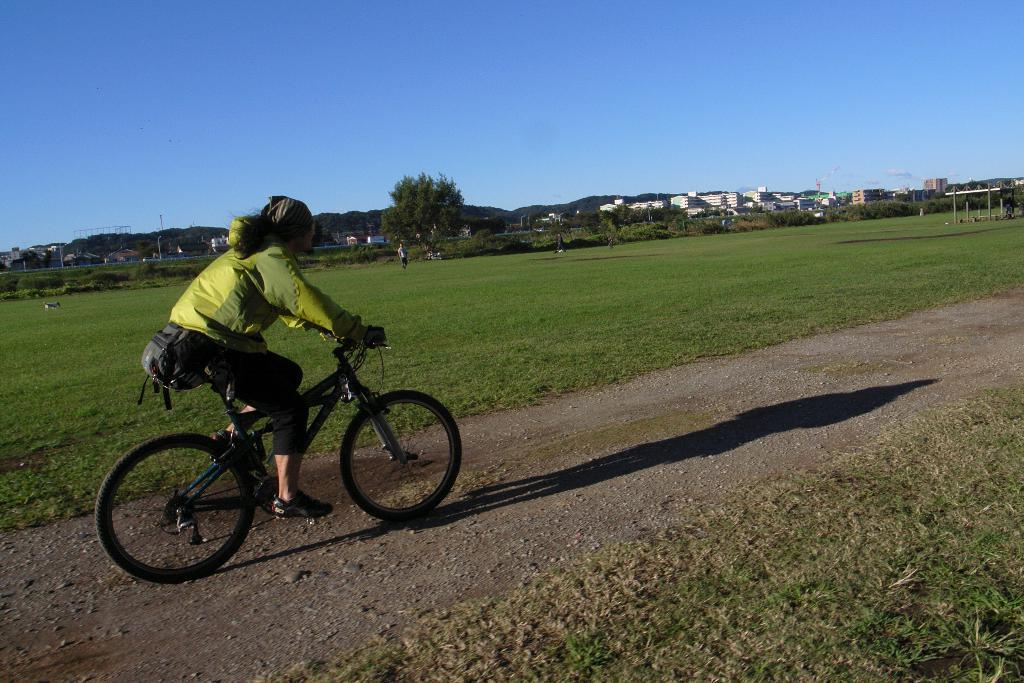What is the main subject of the image? There is a person riding a bicycle in the image. Where is the person riding the bicycle? The person is on the road. What type of natural environment can be seen in the image? There is grass visible in the image, and there are trees as well. What type of man-made structures are present in the image? There are buildings in the image. What type of flag can be seen flying over the harbor in the image? There is no harbor or flag present in the image; it features a person riding a bicycle on the road with grass, trees, and buildings in the background. 